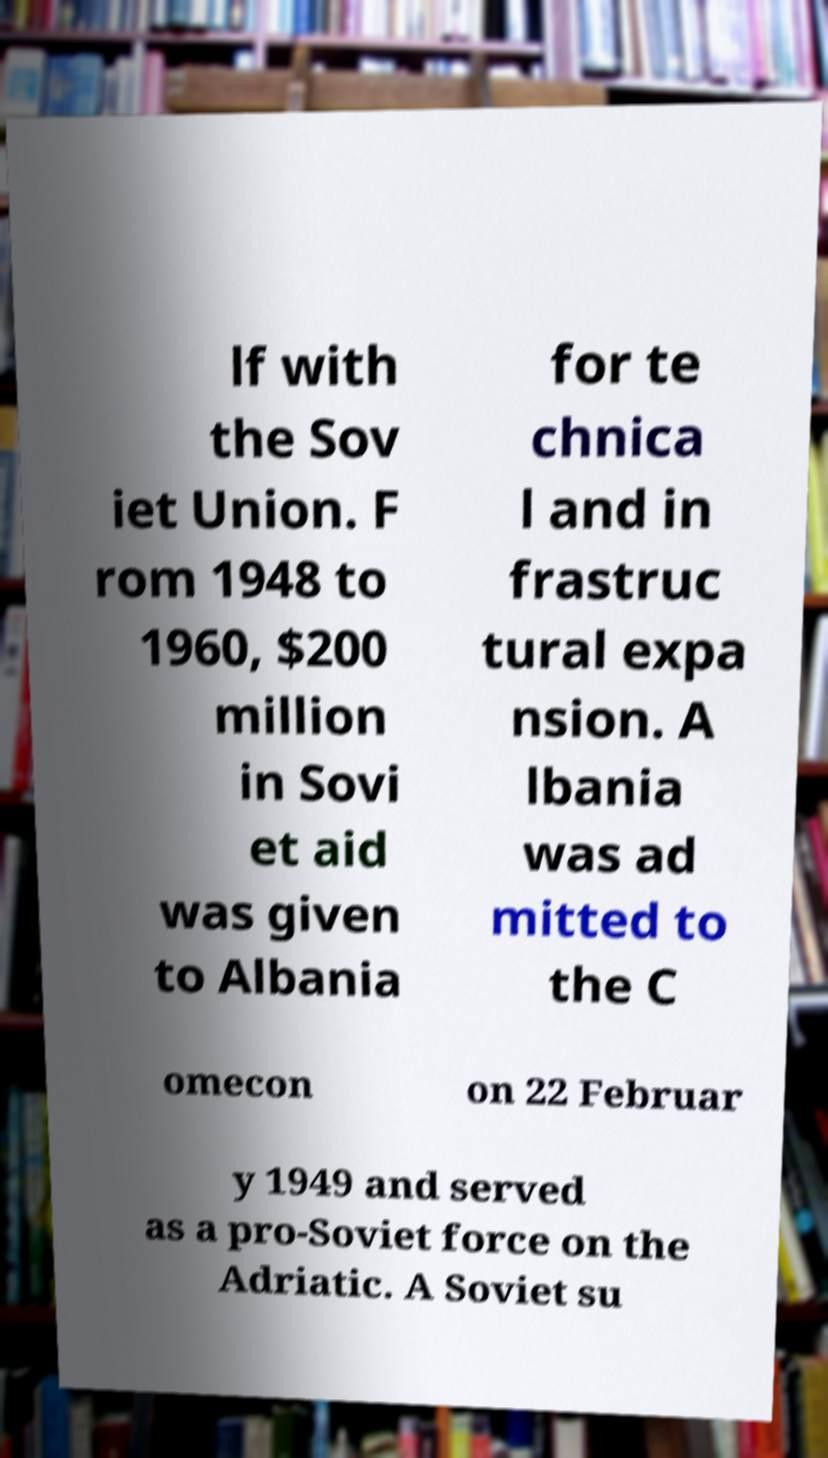Could you assist in decoding the text presented in this image and type it out clearly? lf with the Sov iet Union. F rom 1948 to 1960, $200 million in Sovi et aid was given to Albania for te chnica l and in frastruc tural expa nsion. A lbania was ad mitted to the C omecon on 22 Februar y 1949 and served as a pro-Soviet force on the Adriatic. A Soviet su 